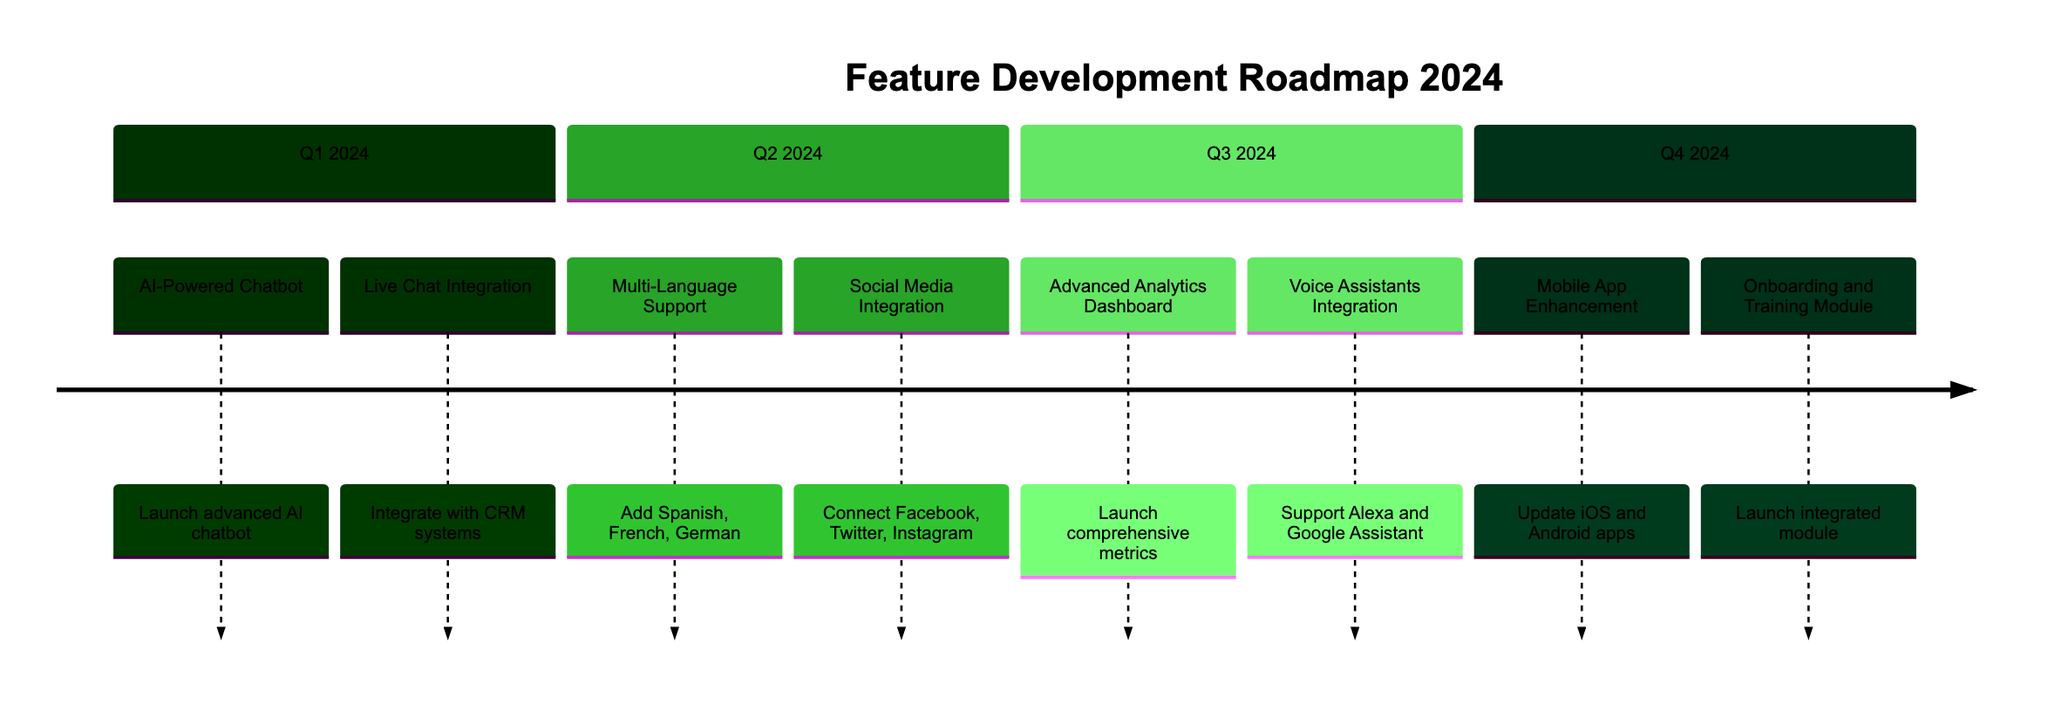What features are released in Q1 2024? In Q1 2024, the features listed are "AI-Powered Chatbot" and "Live Chat Integration". These features are prominently displayed under the section for Q1 2024 in the timeline diagram.
Answer: AI-Powered Chatbot, Live Chat Integration How many features are released in Q2 2024? In Q2 2024, there are two features shown: "Multi-Language Support" and "Social Media Integration". Each feature is distinctly noted under this quarter's section.
Answer: 2 What is the main focus of the features released in Q3 2024? The features in Q3 2024 are focused on analytics and support integration, as seen with "Advanced Analytics Dashboard" for metrics tracking and "Voice Assistants Integration" for voice support. The descriptions emphasize improved analytics and integration capabilities.
Answer: Analytics and support integration Which quarter has a feature related to mobile applications? The feature related to mobile applications, "Mobile App Enhancement", is released in Q4 2024. This is clearly indicated within the Q4 section of the timeline.
Answer: Q4 2024 What language supports are introduced in Q2 2024? The languages introduced in Q2 2024 for support are Spanish, French, and German, as stated in the description for the feature "Multi-Language Support".
Answer: Spanish, French, German Which feature offers integration with social media in 2024? The "Social Media Integration" feature is the one that offers this capability, and it is set to be released in Q2 2024 according to the timeline details.
Answer: Social Media Integration What is the purpose of the "Onboarding and Training Module" released in Q4 2024? The purpose of the "Onboarding and Training Module" is to quickly help new users get up to speed with the product. This is clearly stated in the feature’s description under Q4 2024.
Answer: Help new users get up to speed How many quarters feature advanced analytics capabilities? Only Q3 2024 features advanced analytics capabilities with the "Advanced Analytics Dashboard", indicating a concentrated focus in that quarter on analytics tools.
Answer: 1 What is the last feature listed in the timeline? The last feature listed in the timeline is the "Onboarding and Training Module", which is under the Q4 2024 section, making it the concluding feature of the roadmap.
Answer: Onboarding and Training Module 